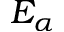<formula> <loc_0><loc_0><loc_500><loc_500>E _ { \alpha }</formula> 